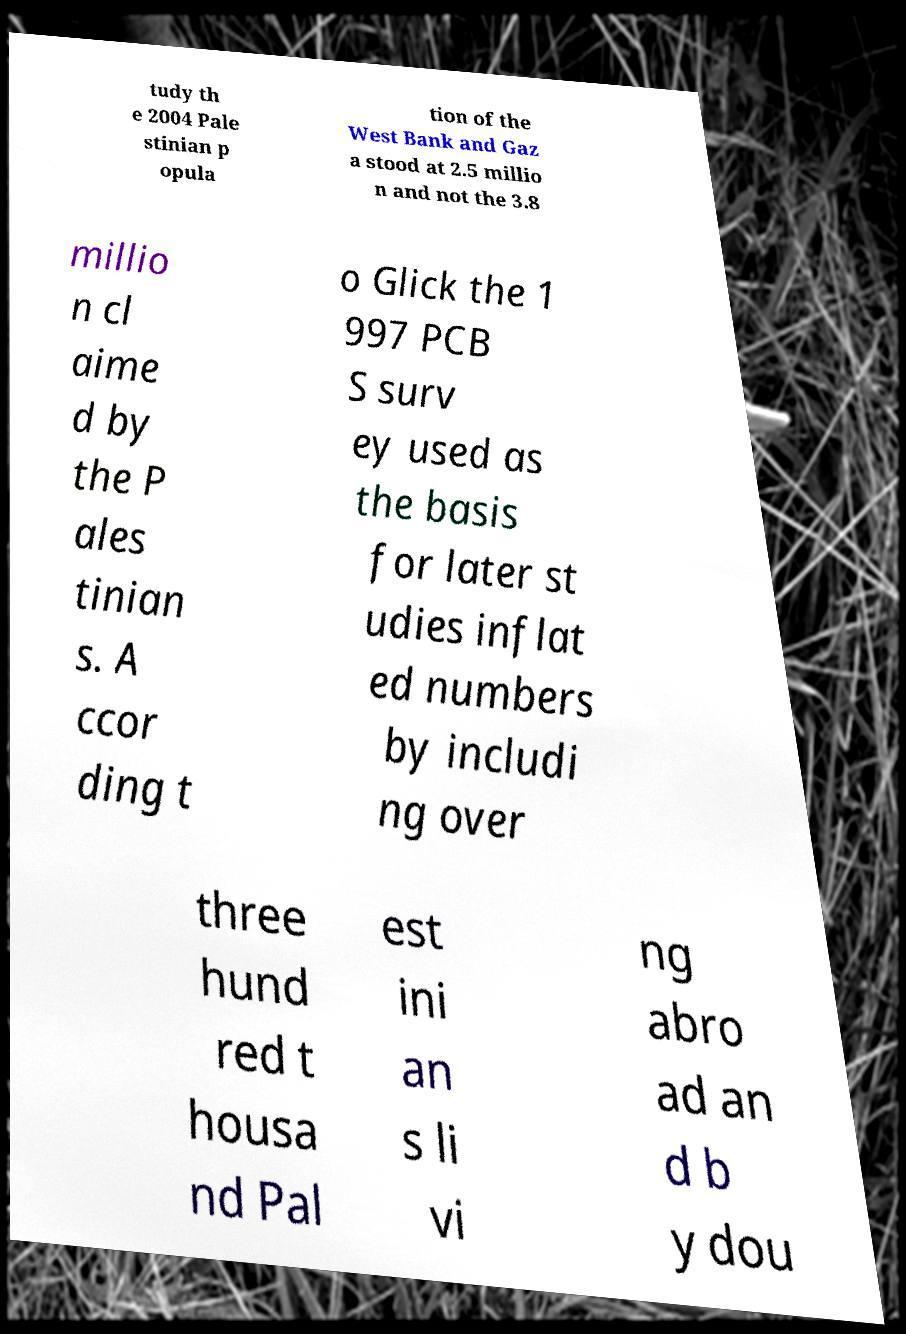For documentation purposes, I need the text within this image transcribed. Could you provide that? tudy th e 2004 Pale stinian p opula tion of the West Bank and Gaz a stood at 2.5 millio n and not the 3.8 millio n cl aime d by the P ales tinian s. A ccor ding t o Glick the 1 997 PCB S surv ey used as the basis for later st udies inflat ed numbers by includi ng over three hund red t housa nd Pal est ini an s li vi ng abro ad an d b y dou 